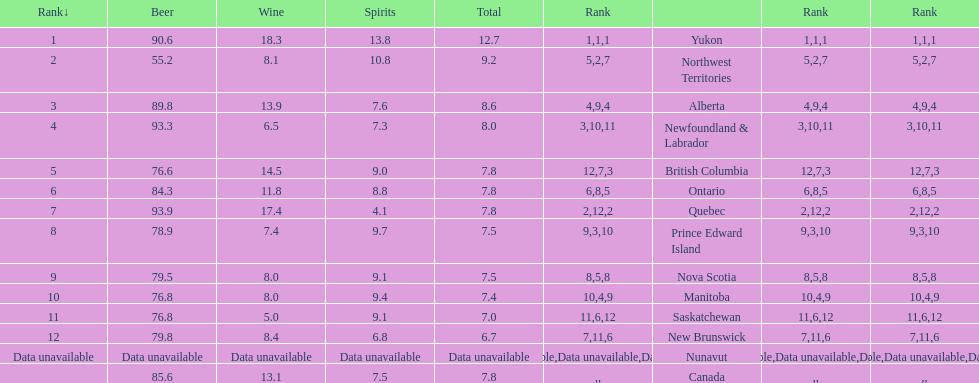Quebuec had a beer consumption of 93.9, what was their spirit consumption? 4.1. 